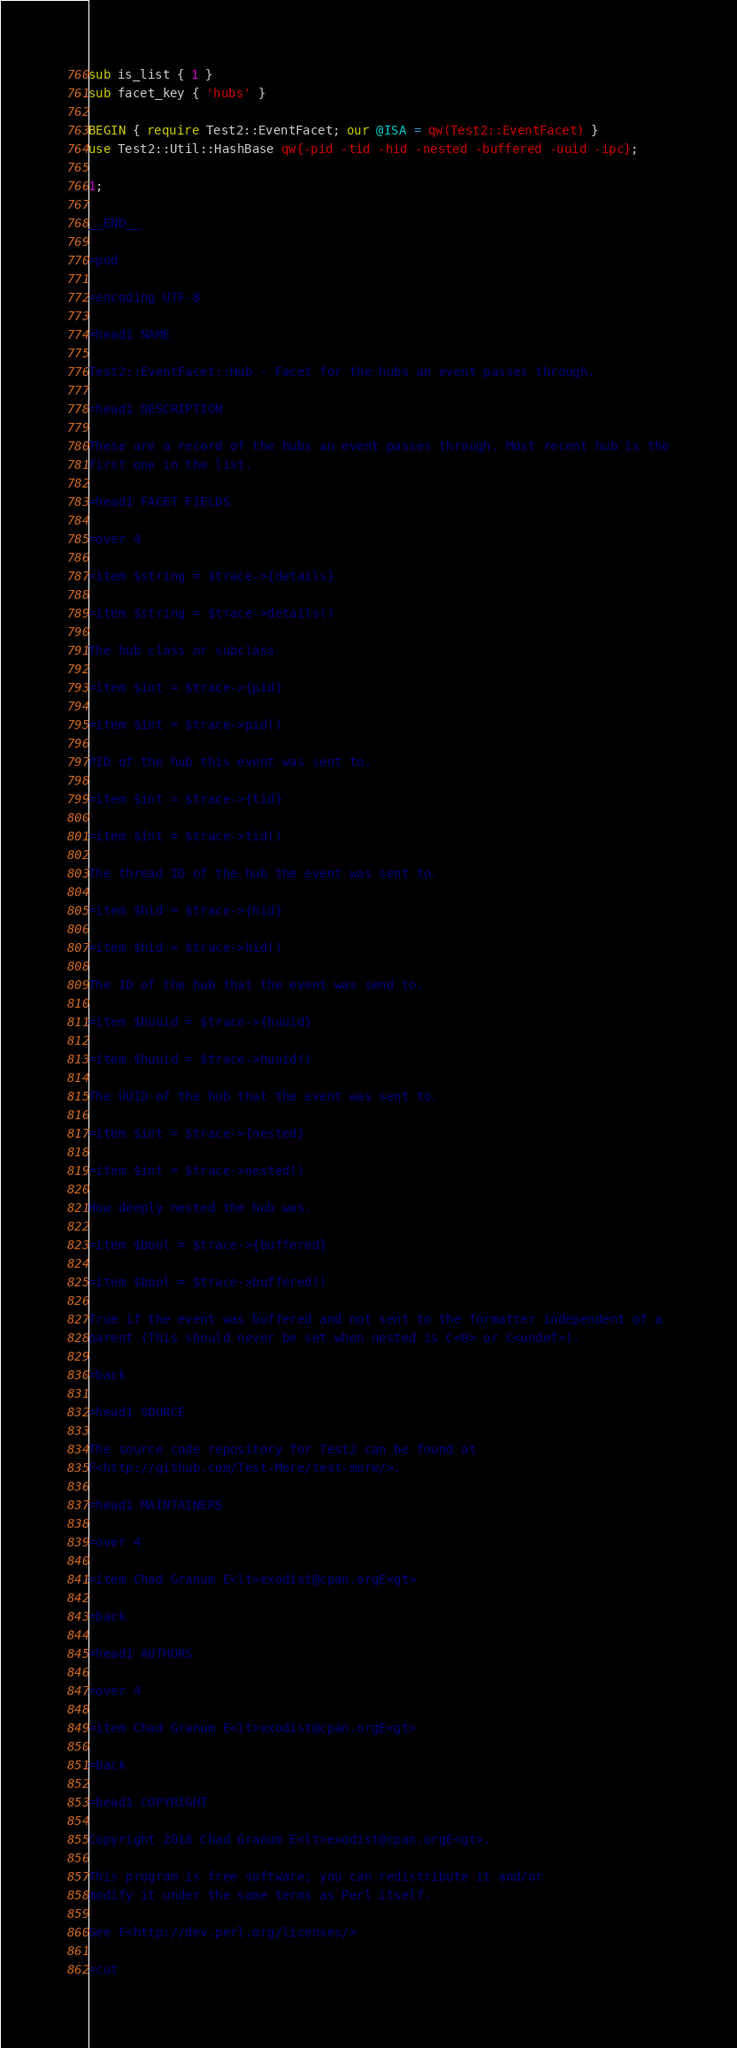Convert code to text. <code><loc_0><loc_0><loc_500><loc_500><_Perl_>sub is_list { 1 }
sub facet_key { 'hubs' }

BEGIN { require Test2::EventFacet; our @ISA = qw(Test2::EventFacet) }
use Test2::Util::HashBase qw{-pid -tid -hid -nested -buffered -uuid -ipc};

1;

__END__

=pod

=encoding UTF-8

=head1 NAME

Test2::EventFacet::Hub - Facet for the hubs an event passes through.

=head1 DESCRIPTION

These are a record of the hubs an event passes through. Most recent hub is the
first one in the list.

=head1 FACET FIELDS

=over 4

=item $string = $trace->{details}

=item $string = $trace->details()

The hub class or subclass

=item $int = $trace->{pid}

=item $int = $trace->pid()

PID of the hub this event was sent to.

=item $int = $trace->{tid}

=item $int = $trace->tid()

The thread ID of the hub the event was sent to.

=item $hid = $trace->{hid}

=item $hid = $trace->hid()

The ID of the hub that the event was send to.

=item $huuid = $trace->{huuid}

=item $huuid = $trace->huuid()

The UUID of the hub that the event was sent to.

=item $int = $trace->{nested}

=item $int = $trace->nested()

How deeply nested the hub was.

=item $bool = $trace->{buffered}

=item $bool = $trace->buffered()

True if the event was buffered and not sent to the formatter independent of a
parent (This should never be set when nested is C<0> or C<undef>).

=back

=head1 SOURCE

The source code repository for Test2 can be found at
F<http://github.com/Test-More/test-more/>.

=head1 MAINTAINERS

=over 4

=item Chad Granum E<lt>exodist@cpan.orgE<gt>

=back

=head1 AUTHORS

=over 4

=item Chad Granum E<lt>exodist@cpan.orgE<gt>

=back

=head1 COPYRIGHT

Copyright 2018 Chad Granum E<lt>exodist@cpan.orgE<gt>.

This program is free software; you can redistribute it and/or
modify it under the same terms as Perl itself.

See F<http://dev.perl.org/licenses/>

=cut
</code> 